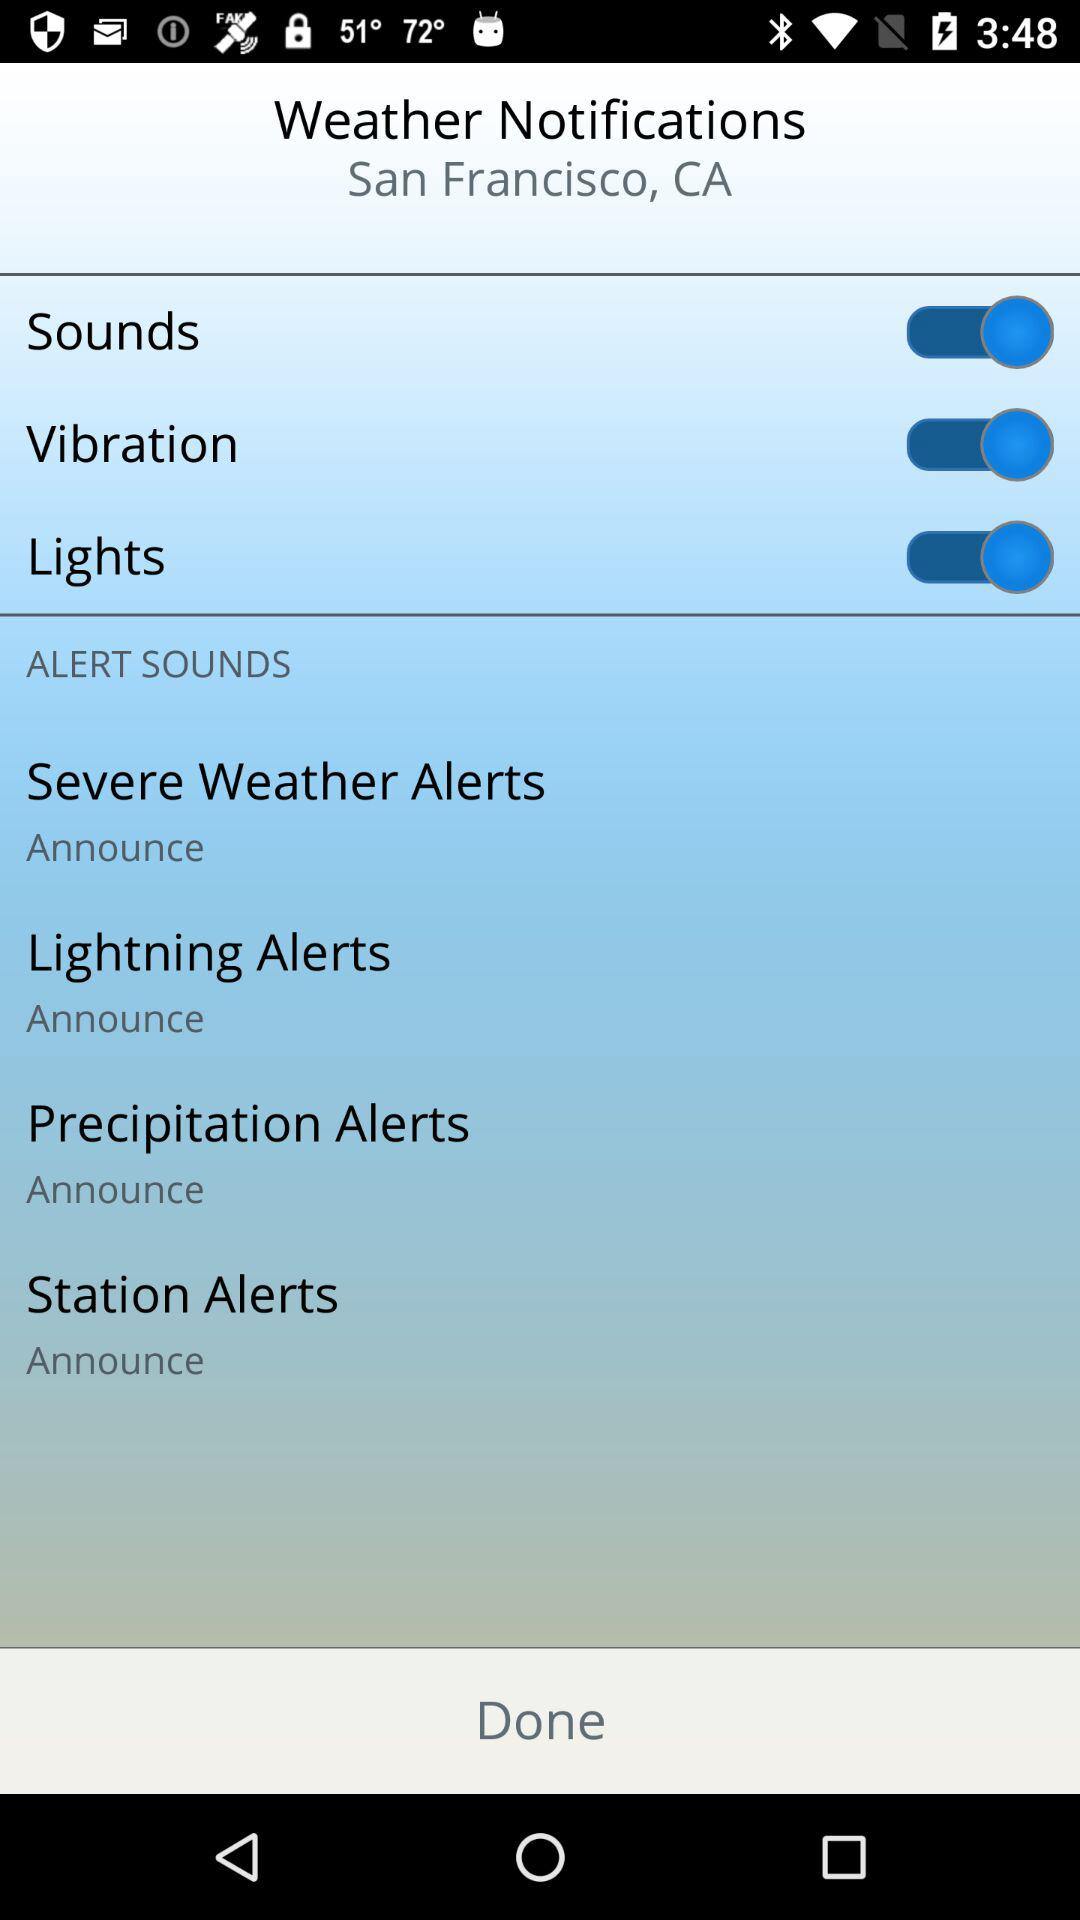What is the setting for station alerts in "ALERT SOUNDS"? The setting is "Announce". 